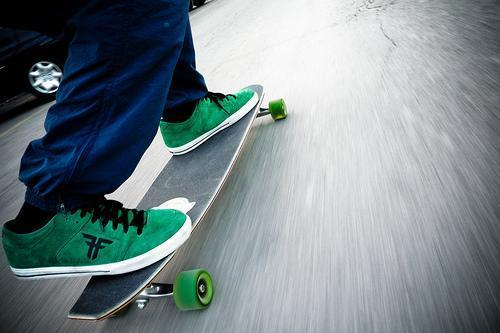How many skateboards are there?
Give a very brief answer. 1. 